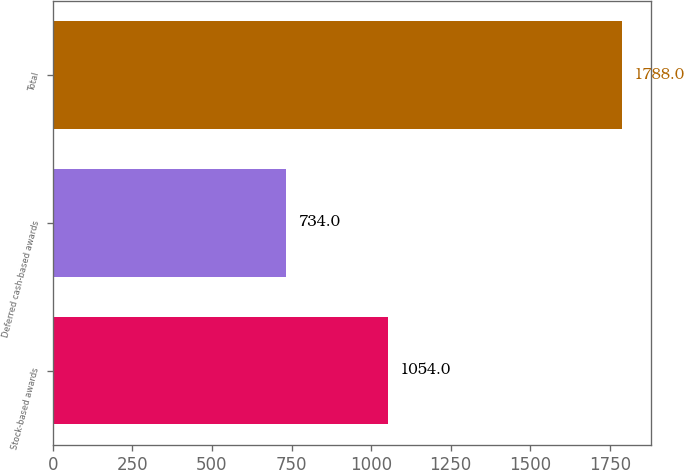<chart> <loc_0><loc_0><loc_500><loc_500><bar_chart><fcel>Stock-based awards<fcel>Deferred cash-based awards<fcel>Total<nl><fcel>1054<fcel>734<fcel>1788<nl></chart> 